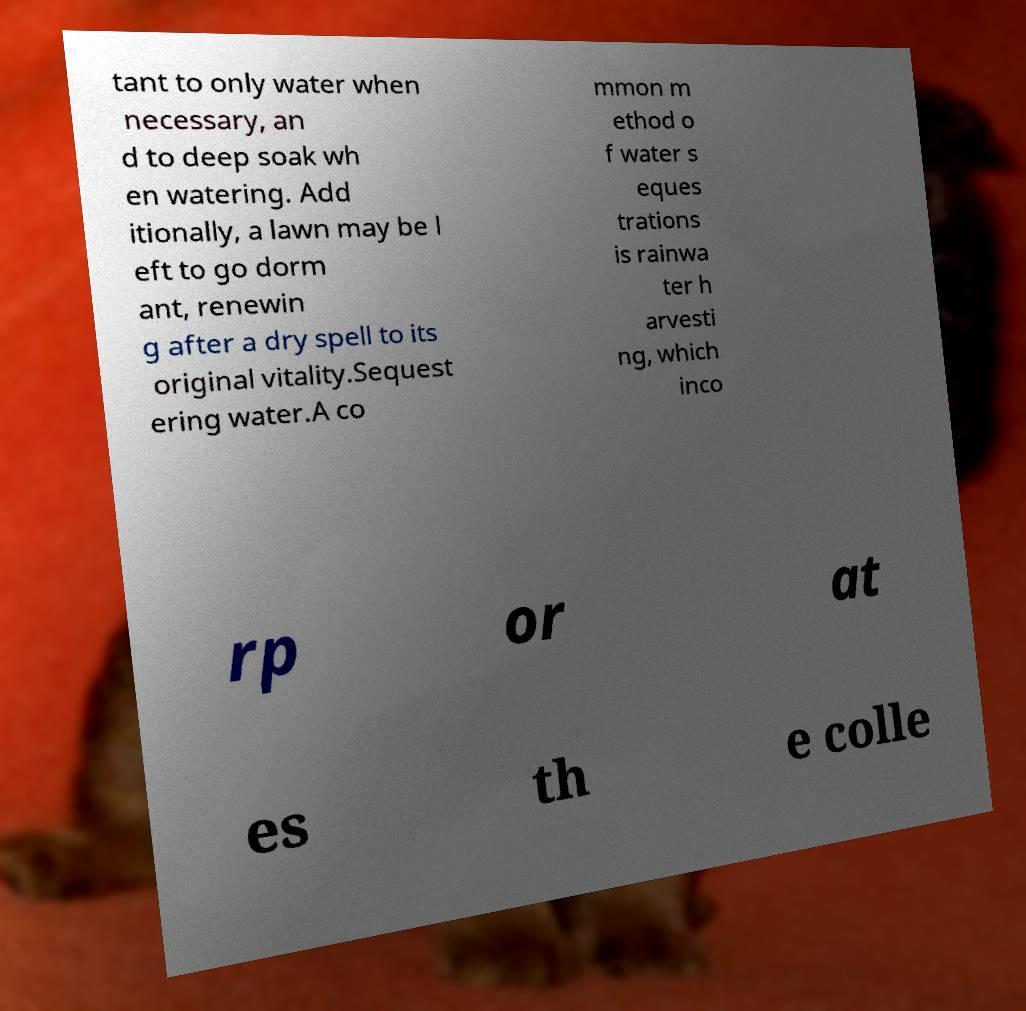What messages or text are displayed in this image? I need them in a readable, typed format. tant to only water when necessary, an d to deep soak wh en watering. Add itionally, a lawn may be l eft to go dorm ant, renewin g after a dry spell to its original vitality.Sequest ering water.A co mmon m ethod o f water s eques trations is rainwa ter h arvesti ng, which inco rp or at es th e colle 